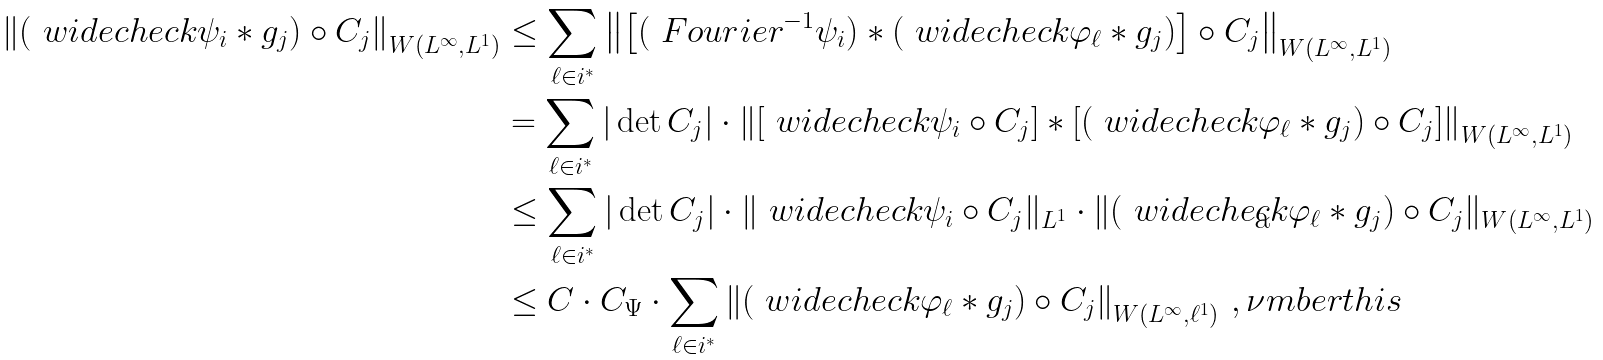<formula> <loc_0><loc_0><loc_500><loc_500>\left \| ( \ w i d e c h e c k { \psi _ { i } } \ast g _ { j } ) \circ C _ { j } \right \| _ { W ( L ^ { \infty } , L ^ { 1 } ) } & \leq \sum _ { \ell \in i ^ { \ast } } \left \| \left [ ( \ F o u r i e r ^ { - 1 } \psi _ { i } ) \ast ( \ w i d e c h e c k { \varphi _ { \ell } } \ast g _ { j } ) \right ] \circ C _ { j } \right \| _ { W ( L ^ { \infty } , L ^ { 1 } ) } \\ & = \sum _ { \ell \in i ^ { \ast } } | \det C _ { j } | \cdot \left \| \left [ \ w i d e c h e c k { \psi _ { i } } \circ C _ { j } \right ] \ast \left [ ( \ w i d e c h e c k { \varphi _ { \ell } } \ast g _ { j } ) \circ C _ { j } \right ] \right \| _ { W ( L ^ { \infty } , L ^ { 1 } ) } \\ & \leq \sum _ { \ell \in i ^ { \ast } } | \det C _ { j } | \cdot \| \ w i d e c h e c k { \psi _ { i } } \circ C _ { j } \| _ { L ^ { 1 } } \cdot \| ( \ w i d e c h e c k { \varphi _ { \ell } } \ast g _ { j } ) \circ C _ { j } \| _ { W ( L ^ { \infty } , L ^ { 1 } ) } \\ & \leq C \cdot C _ { \Psi } \cdot \sum _ { \ell \in i ^ { \ast } } \left \| ( \ w i d e c h e c k { \varphi _ { \ell } } \ast g _ { j } ) \circ C _ { j } \right \| _ { W ( L ^ { \infty } , \ell ^ { 1 } ) } \, , \nu m b e r t h i s</formula> 